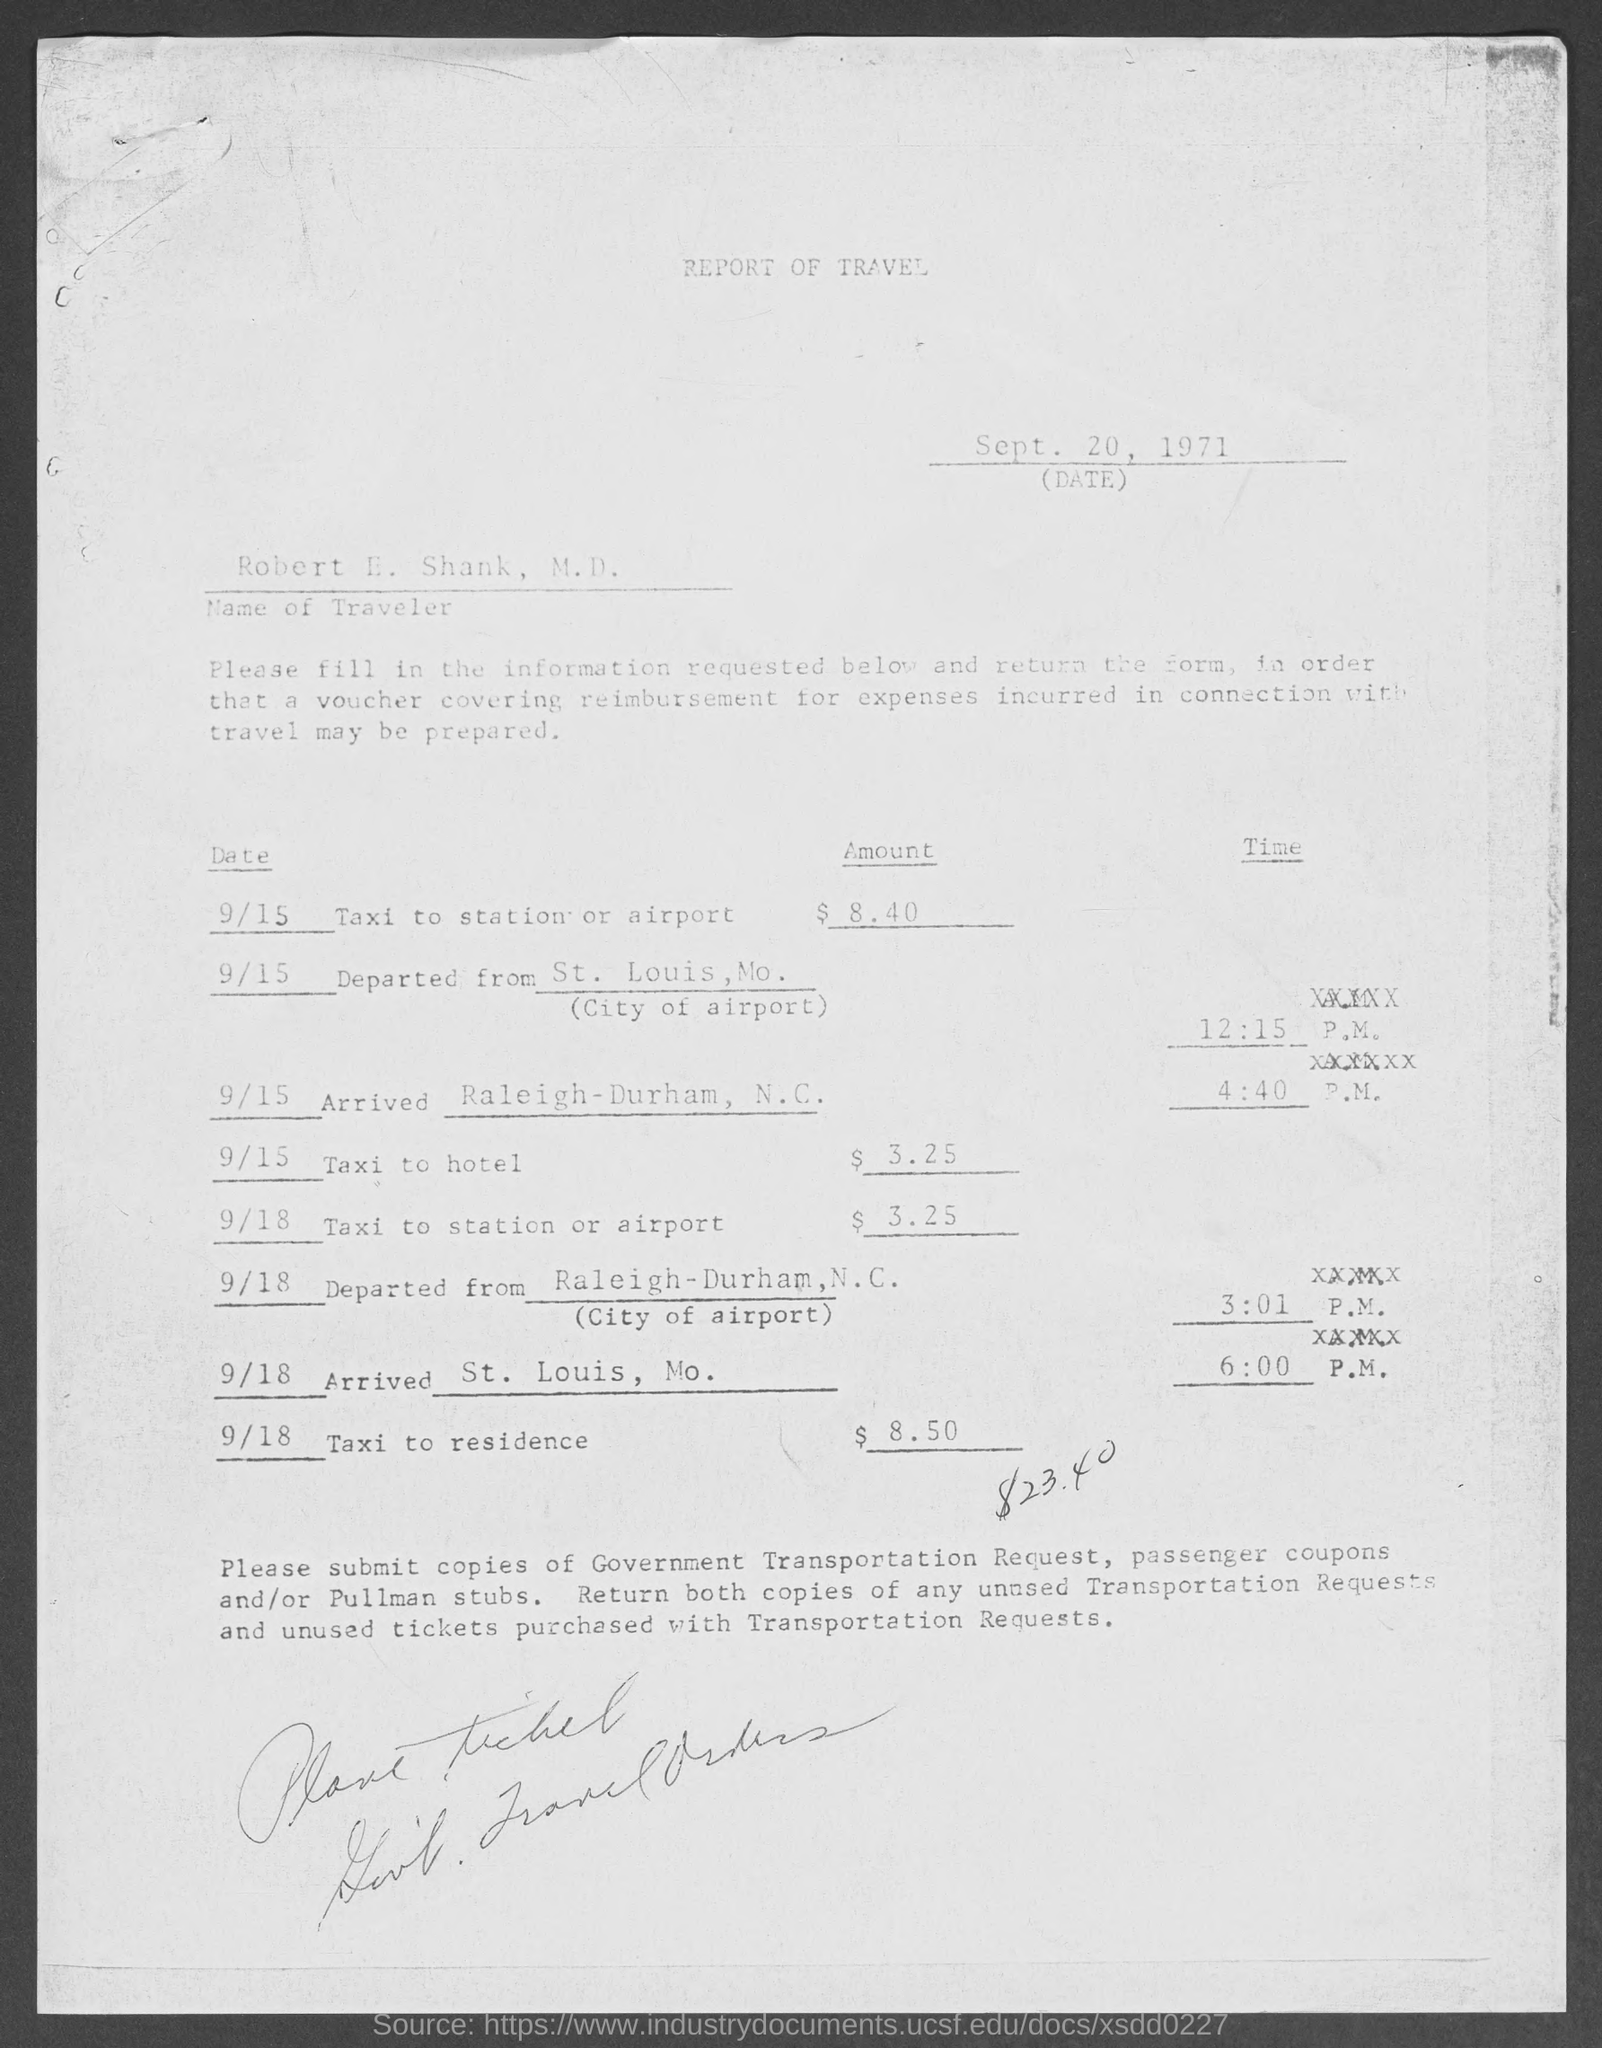What is the name of traveler ?
Provide a short and direct response. Robert E. Shank, M.D. When is the report of travel dated?
Keep it short and to the point. Sept. 20, 1971. 